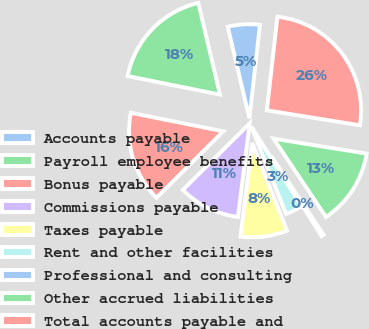<chart> <loc_0><loc_0><loc_500><loc_500><pie_chart><fcel>Accounts payable<fcel>Payroll employee benefits<fcel>Bonus payable<fcel>Commissions payable<fcel>Taxes payable<fcel>Rent and other facilities<fcel>Professional and consulting<fcel>Other accrued liabilities<fcel>Total accounts payable and<nl><fcel>5.48%<fcel>18.15%<fcel>15.62%<fcel>10.55%<fcel>8.01%<fcel>2.95%<fcel>0.41%<fcel>13.08%<fcel>25.75%<nl></chart> 